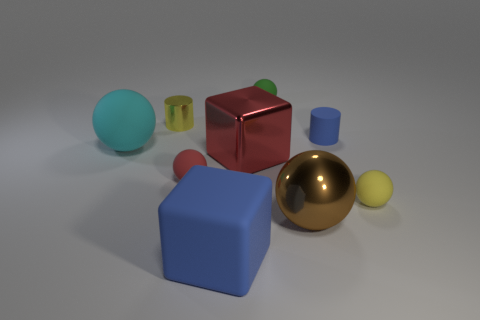Subtract 1 balls. How many balls are left? 4 Subtract all large rubber balls. How many balls are left? 4 Subtract all brown balls. How many balls are left? 4 Subtract all blue spheres. Subtract all cyan blocks. How many spheres are left? 5 Add 1 large red metal objects. How many objects exist? 10 Subtract all blocks. How many objects are left? 7 Subtract 0 yellow blocks. How many objects are left? 9 Subtract all cyan matte cubes. Subtract all tiny red matte objects. How many objects are left? 8 Add 2 rubber cylinders. How many rubber cylinders are left? 3 Add 2 cyan cubes. How many cyan cubes exist? 2 